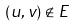<formula> <loc_0><loc_0><loc_500><loc_500>( u , v ) \notin E</formula> 